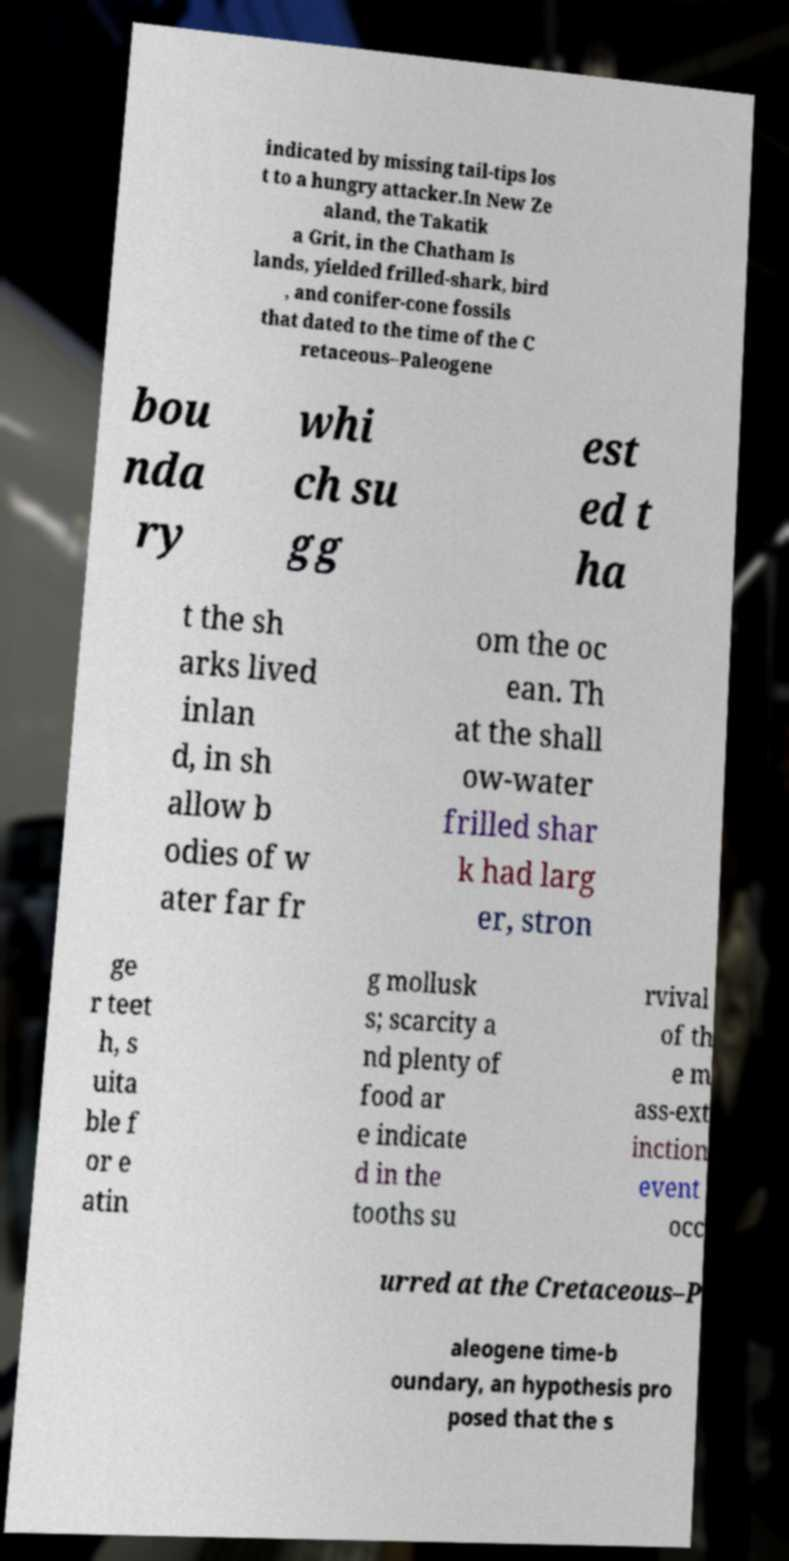I need the written content from this picture converted into text. Can you do that? indicated by missing tail-tips los t to a hungry attacker.In New Ze aland, the Takatik a Grit, in the Chatham Is lands, yielded frilled-shark, bird , and conifer-cone fossils that dated to the time of the C retaceous–Paleogene bou nda ry whi ch su gg est ed t ha t the sh arks lived inlan d, in sh allow b odies of w ater far fr om the oc ean. Th at the shall ow-water frilled shar k had larg er, stron ge r teet h, s uita ble f or e atin g mollusk s; scarcity a nd plenty of food ar e indicate d in the tooths su rvival of th e m ass-ext inction event occ urred at the Cretaceous–P aleogene time-b oundary, an hypothesis pro posed that the s 